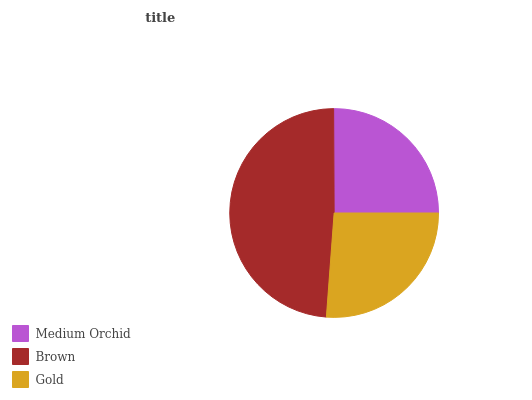Is Medium Orchid the minimum?
Answer yes or no. Yes. Is Brown the maximum?
Answer yes or no. Yes. Is Gold the minimum?
Answer yes or no. No. Is Gold the maximum?
Answer yes or no. No. Is Brown greater than Gold?
Answer yes or no. Yes. Is Gold less than Brown?
Answer yes or no. Yes. Is Gold greater than Brown?
Answer yes or no. No. Is Brown less than Gold?
Answer yes or no. No. Is Gold the high median?
Answer yes or no. Yes. Is Gold the low median?
Answer yes or no. Yes. Is Brown the high median?
Answer yes or no. No. Is Medium Orchid the low median?
Answer yes or no. No. 